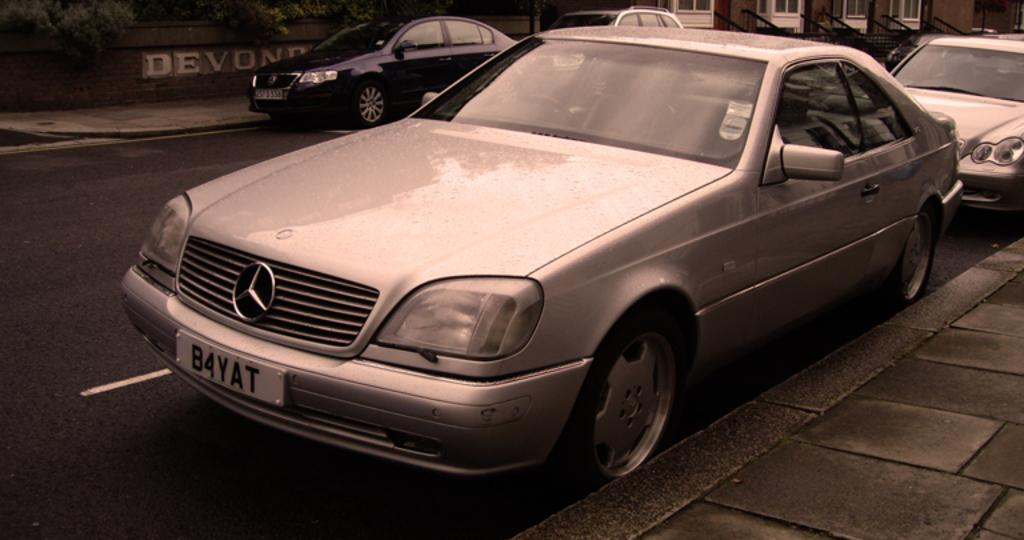Provide a one-sentence caption for the provided image. Silver Mercedes park on the street side in front of the Devond wall. 